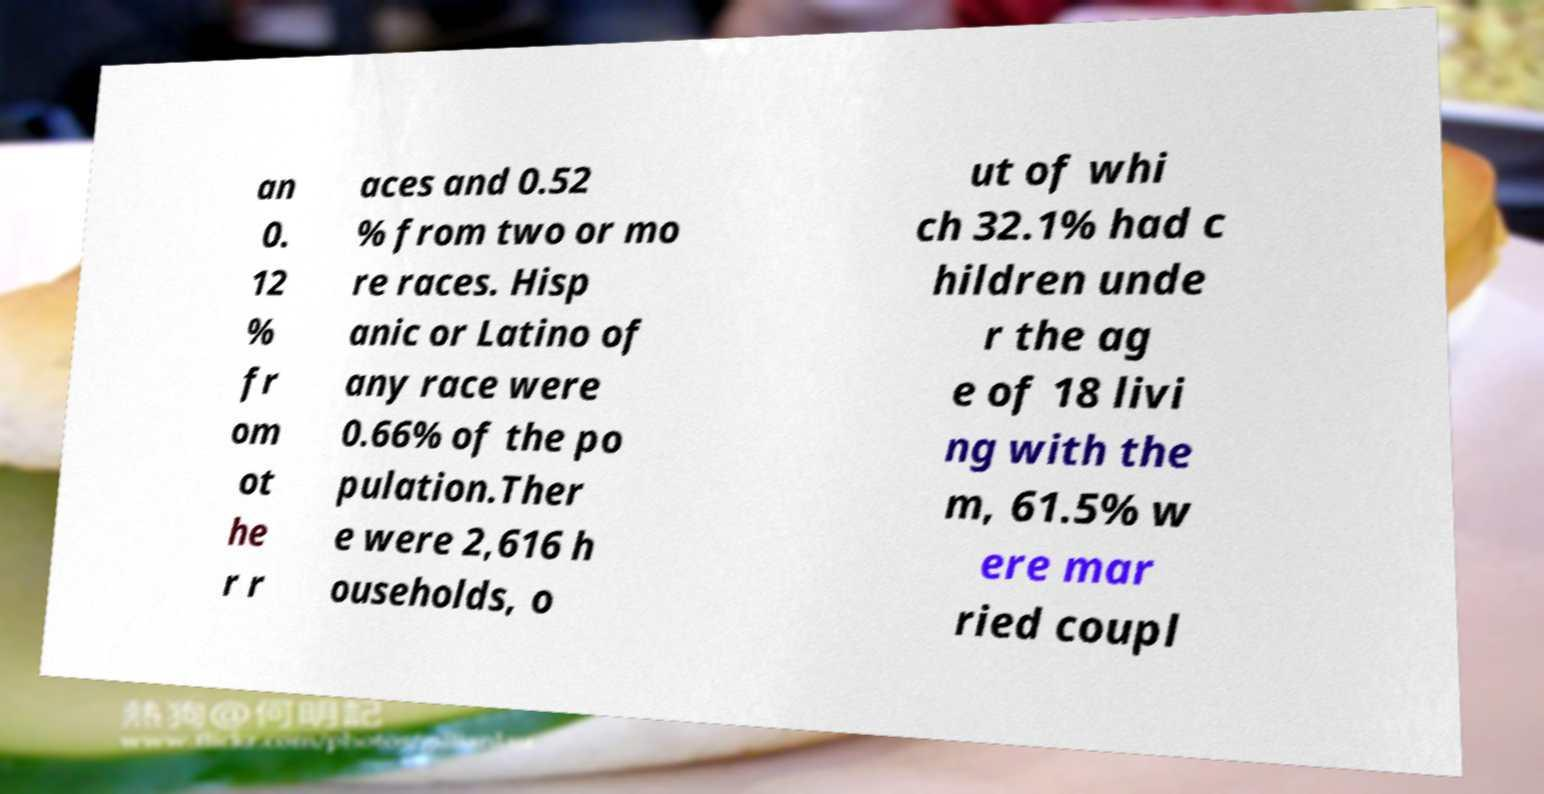For documentation purposes, I need the text within this image transcribed. Could you provide that? an 0. 12 % fr om ot he r r aces and 0.52 % from two or mo re races. Hisp anic or Latino of any race were 0.66% of the po pulation.Ther e were 2,616 h ouseholds, o ut of whi ch 32.1% had c hildren unde r the ag e of 18 livi ng with the m, 61.5% w ere mar ried coupl 